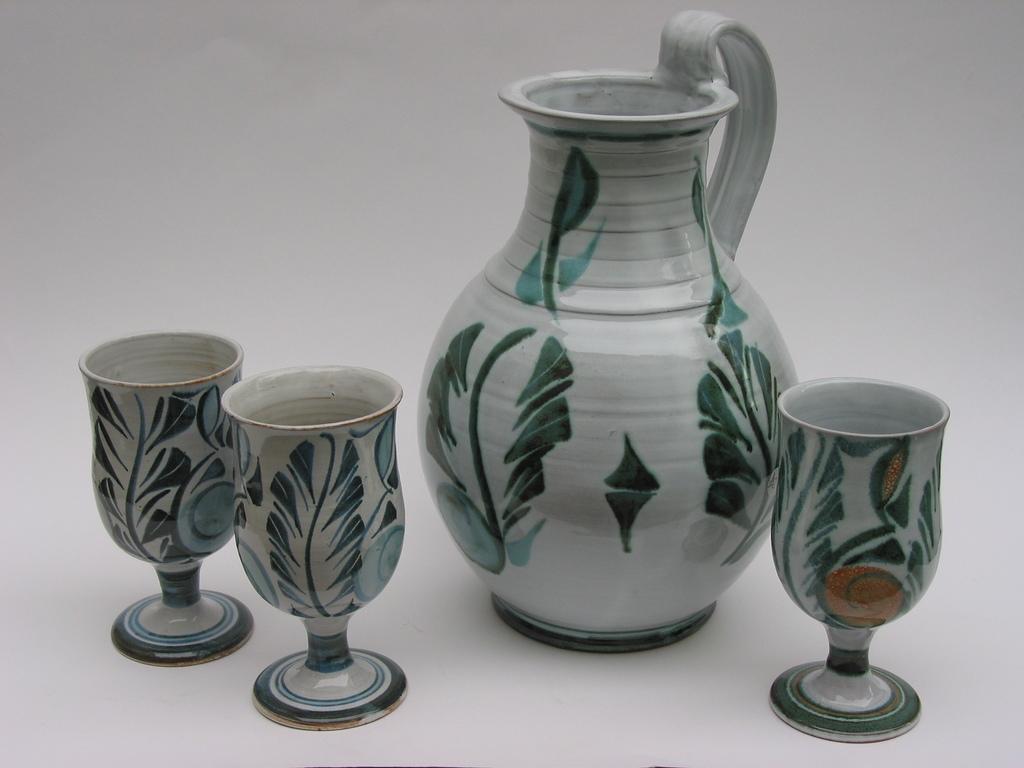Please provide a concise description of this image. In the picture we can see the jar and glasses with some designs on it. 